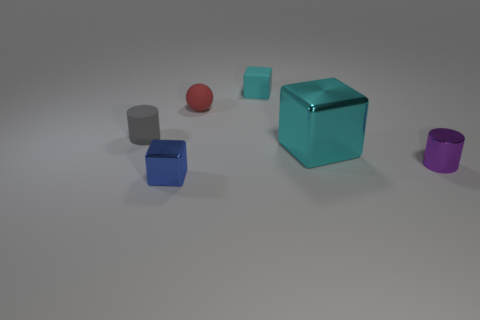Subtract all yellow spheres. Subtract all blue blocks. How many spheres are left? 1 Add 2 gray shiny spheres. How many objects exist? 8 Subtract all cylinders. How many objects are left? 4 Add 1 small blue metal objects. How many small blue metal objects exist? 2 Subtract 0 cyan spheres. How many objects are left? 6 Subtract all cyan shiny blocks. Subtract all cyan metallic objects. How many objects are left? 4 Add 4 purple metal cylinders. How many purple metal cylinders are left? 5 